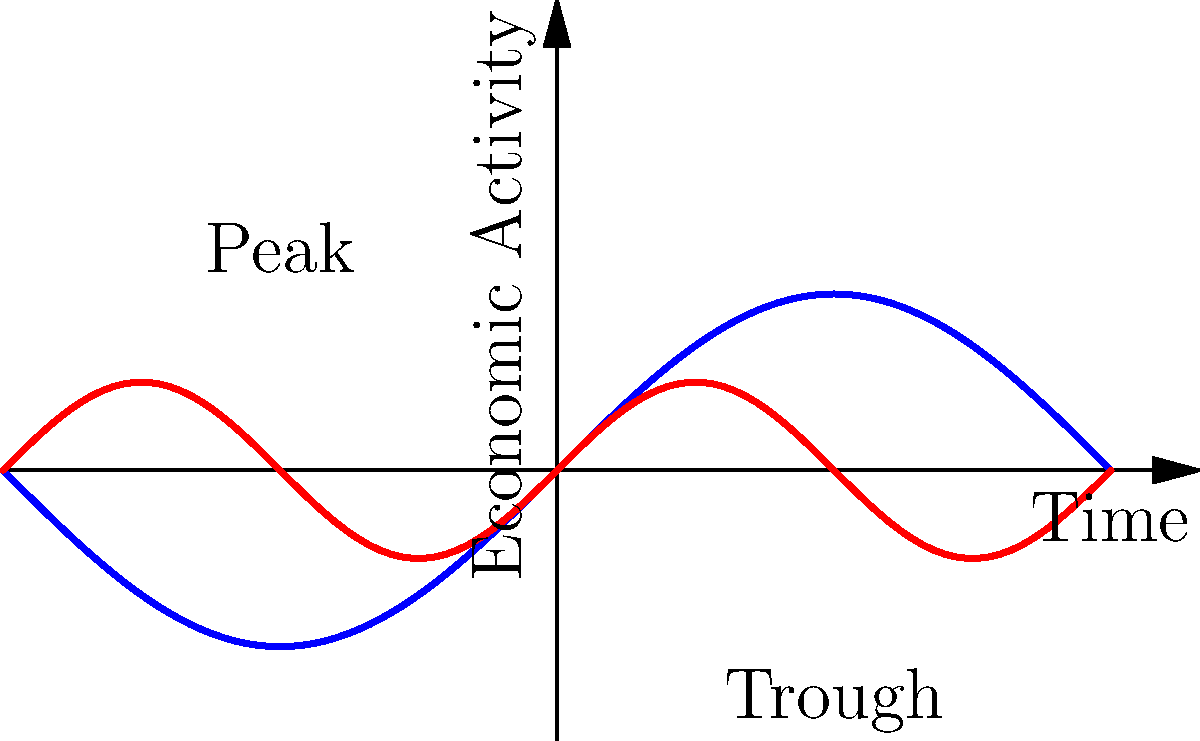Based on the topological features of the global and regional economic cycles shown in the graph, which of the following investment strategies would be most appropriate for a portfolio manager seeking to maximize returns while minimizing risk?

A) Invest heavily in global markets during peak periods
B) Diversify investments across regions with different cycle phases
C) Focus on regional markets during trough periods
D) Maintain a constant allocation regardless of cycle position To answer this question, let's analyze the topological features of the economic cycles presented in the graph:

1. The blue line represents the global economic cycle, which has larger amplitude and longer periods between peaks and troughs.
2. The red line represents the regional economic cycle, which has smaller amplitude and more frequent fluctuations.

Now, let's consider each option:

A) Investing heavily in global markets during peak periods is risky because:
   - Peaks are followed by downturns in the cycle
   - This strategy doesn't account for regional variations

B) Diversifying investments across regions with different cycle phases:
   - Allows for risk mitigation by spreading investments across markets in different stages of their economic cycles
   - Takes advantage of the phase differences between global and regional cycles
   - Provides opportunities to capitalize on growth in some regions while others may be in decline

C) Focusing on regional markets during trough periods:
   - While this might seem like a "buy low" strategy, it concentrates risk in potentially unstable markets
   - Ignores opportunities in other regions that might be in growth phases

D) Maintaining a constant allocation regardless of cycle position:
   - Doesn't take advantage of the cyclical nature of economies
   - Misses opportunities to optimize returns based on market conditions

Given these considerations, option B provides the best balance of risk management and return optimization. By diversifying across regions with different cycle phases, a portfolio manager can:

1. Reduce overall portfolio volatility
2. Capitalize on growth opportunities in different markets
3. Hedge against downturns in specific regions
4. Align with the strategic goal of maximizing returns while minimizing risk

This strategy also aligns with the portfolio manager's role of setting strategic investment goals and overseeing financial analysts' work, as it requires a comprehensive understanding of global economic trends and careful allocation of resources.
Answer: Diversify investments across regions with different cycle phases 